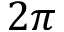<formula> <loc_0><loc_0><loc_500><loc_500>2 \pi</formula> 